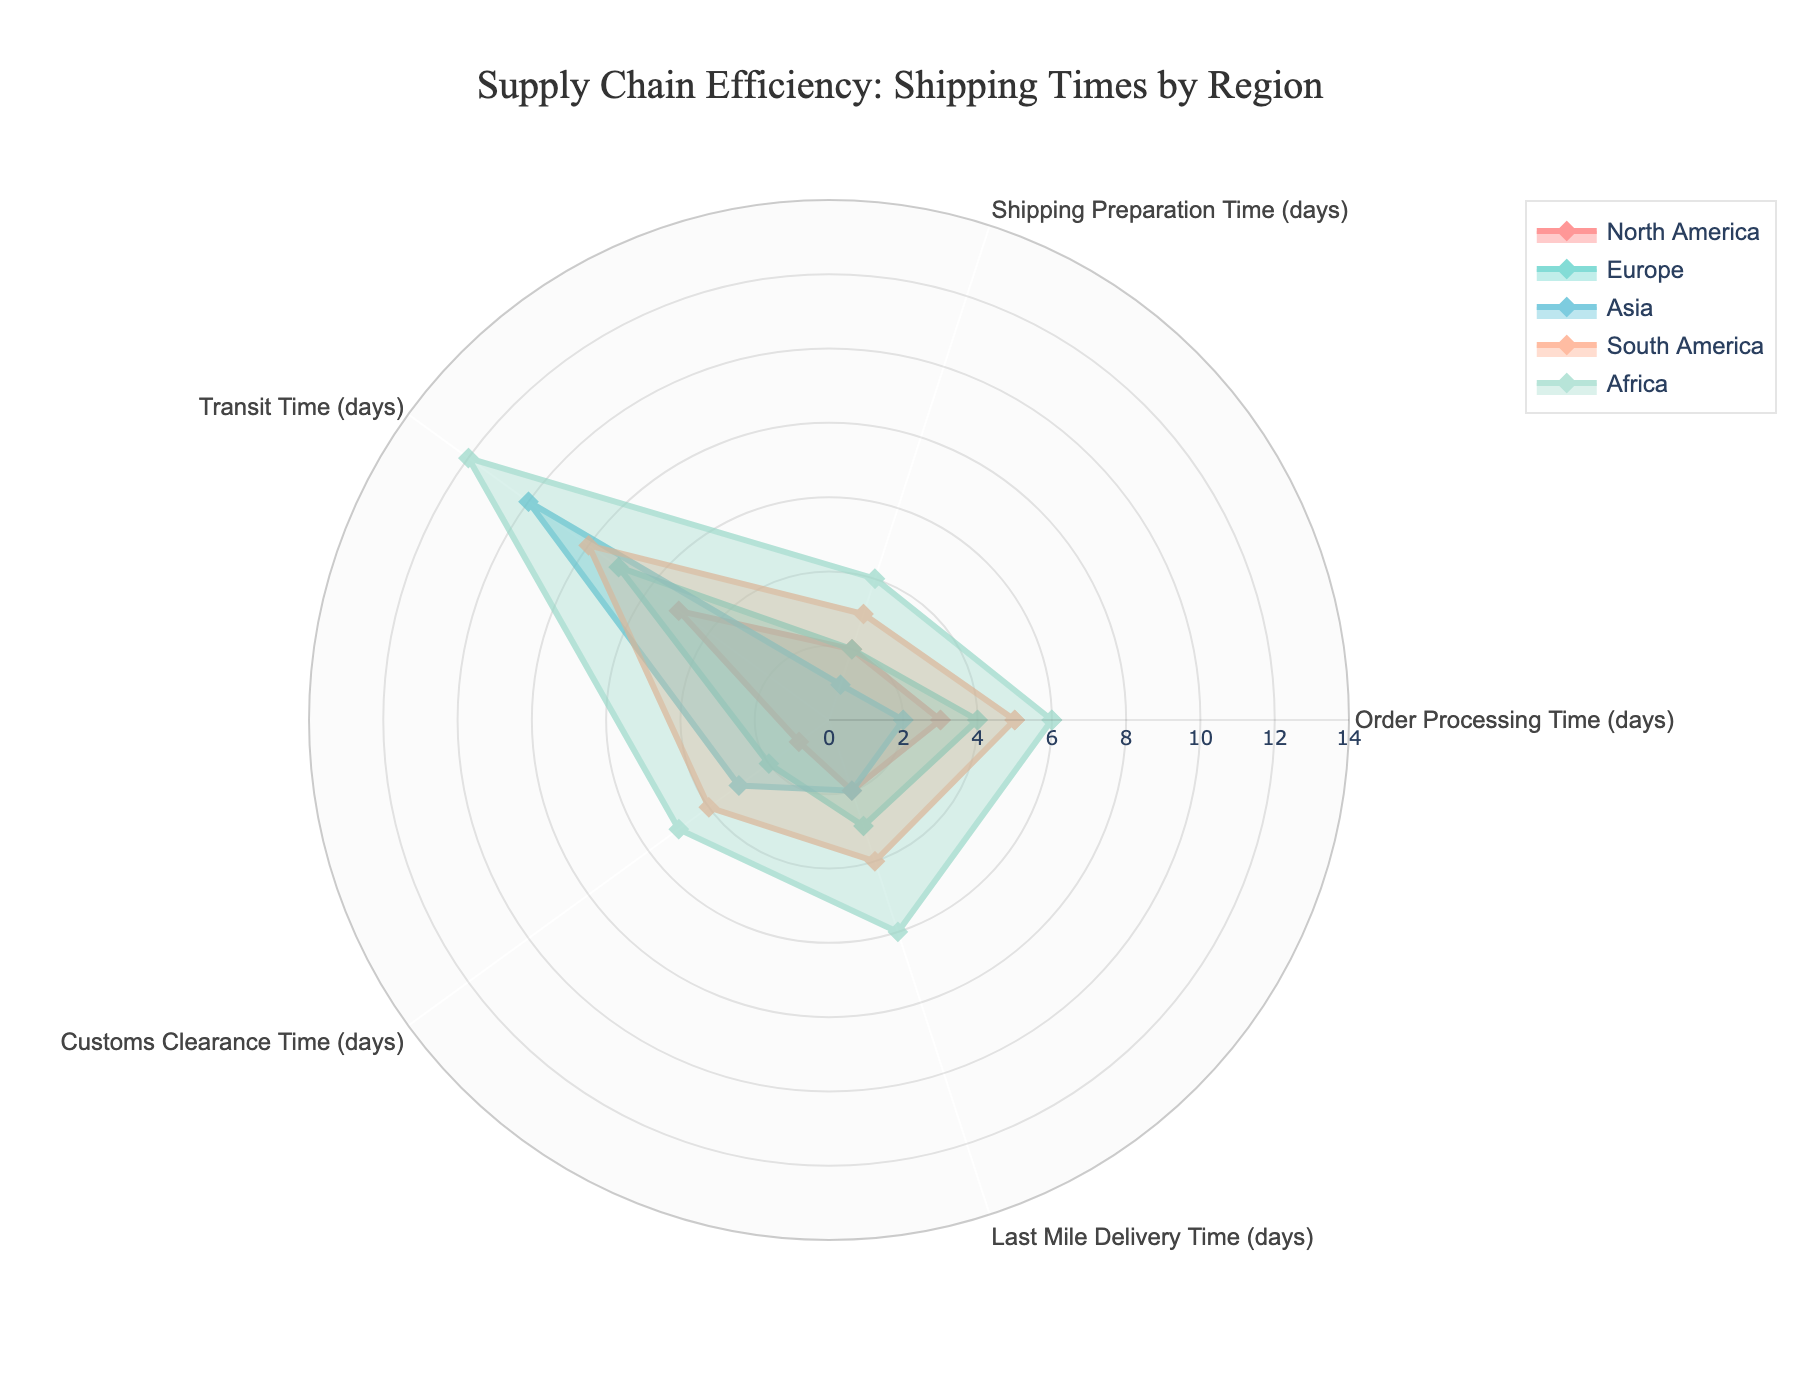What's the title of the radar chart? The title of a chart is usually found at the top and is used to indicate the main topic that the chart covers. In this case, it's visible at the top.
Answer: Supply Chain Efficiency: Shipping Times by Region How many regions are displayed in the radar chart? By counting the distinct colored lines or checking the legend, we can see each region represented.
Answer: 5 Which region has the shortest Order Processing Time? Look at the values for Order Processing Time (days) on the radar chart for each region and identify the smallest value.
Answer: Asia What is the Last Mile Delivery Time for Africa? By locating Africa in the legend and following the data points for Last Mile Delivery Time (days), we can see the specific value.
Answer: 6 days What's the average Transit Time across all regions? Add up the Transit Time values for all regions and divide by the number of regions: (5 + 7 + 10 + 8 + 12) / 5.
Answer: 8.4 days Which region shows the greatest variation in shipping times across all categories? The radar chart will have the region with the most spread-out or unevenly distributed data points, showing the most variance.
Answer: Africa How does the Shipping Preparation Time for North America compare to South America? Check the values for Shipping Preparation Time (days) for both regions and compare them.
Answer: North America has 2 days, South America has 3 days, so North America has a shorter time Which region has the longest Customs Clearance Time and what is it? Look at the Customs Clearance Time (days) for each region and identify the highest value.
Answer: Africa, 5 days What's the combined total time for Order Processing and Transit Time in Europe? Add the Order Processing Time and Transit Time for Europe: 4 + 7.
Answer: 11 days In which category does Asia have the highest value, and what is that value? Look at Asia’s data points for each category and identify the highest number.
Answer: Transit Time, 10 days 